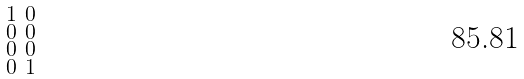Convert formula to latex. <formula><loc_0><loc_0><loc_500><loc_500>\begin{smallmatrix} 1 & 0 \\ 0 & 0 \\ 0 & 0 \\ 0 & 1 \end{smallmatrix}</formula> 